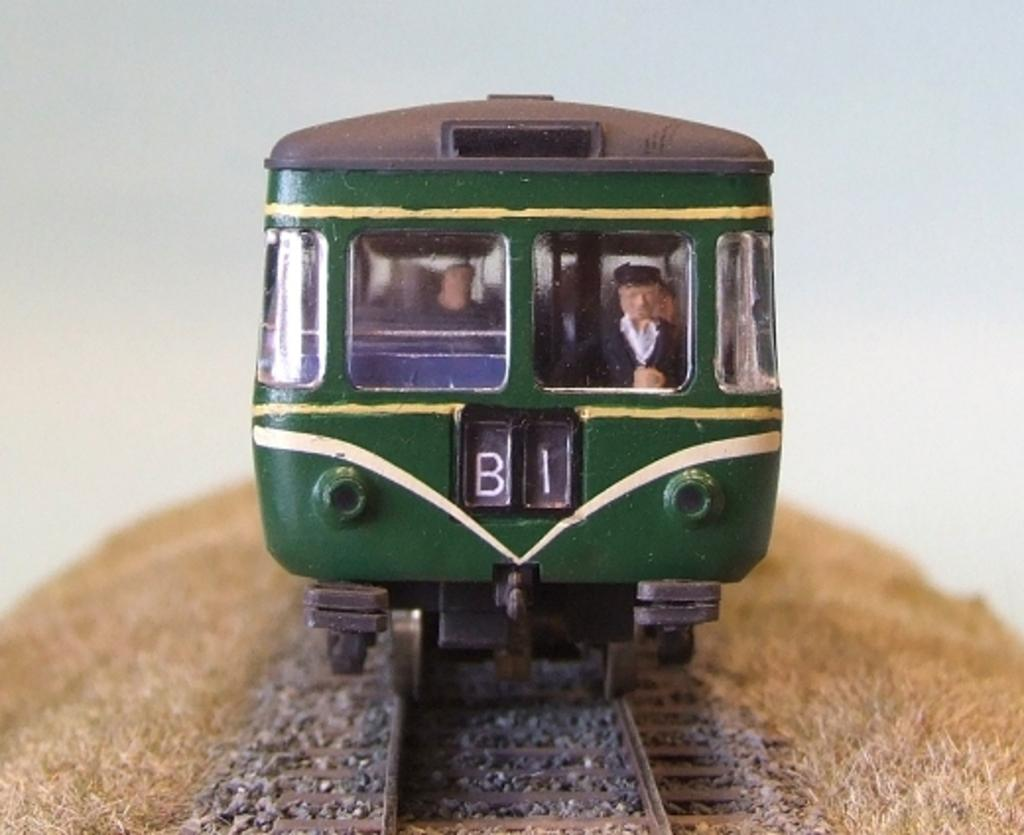What type of toy is present in the image? There is a toy locomotive in the image. What is the toy locomotive situated on? The toy locomotive is on a track. What type of natural environment can be seen in the background of the image? There is grass visible in the background of the image. Where is the nearest store to purchase a toy locomotive in the image? There is no store present in the image, and therefore no such information can be provided. What type of curve can be seen in the track of the toy locomotive in the image? There is no curve visible in the track of the toy locomotive in the image; it appears to be a straight track. 